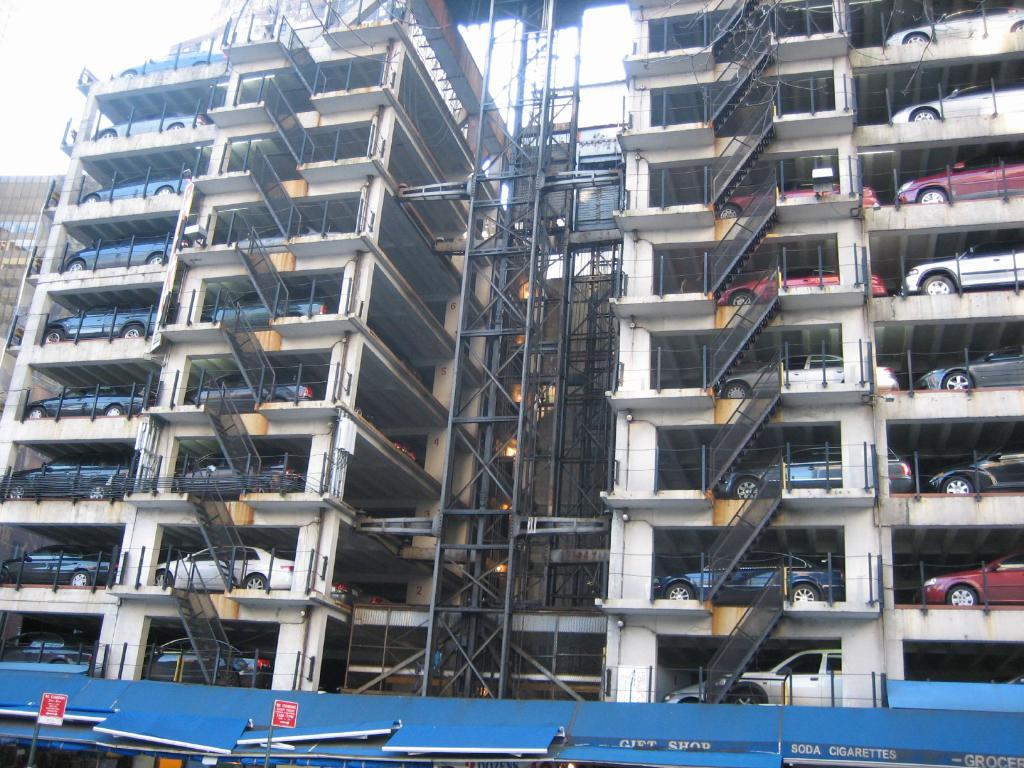What type of area is depicted in the image? The image shows parking lots. What structures can be seen in the parking lots? There are iron grills in the image. What can be seen in the background of the image? The sky is visible in the image. How many roses can be seen in the image? There are no roses present in the image. What are the boys doing in the image? There are no boys present in the image. 